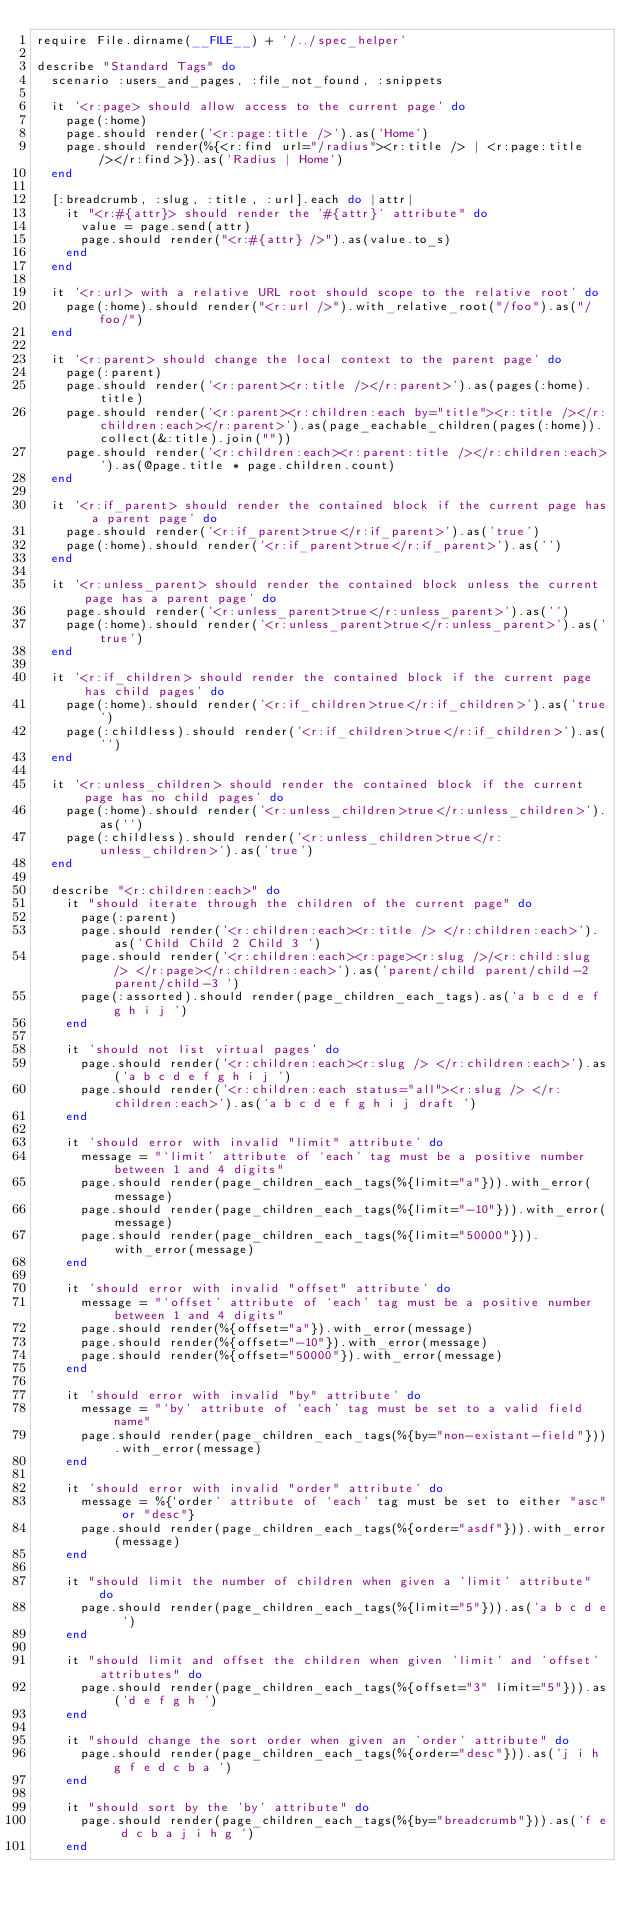<code> <loc_0><loc_0><loc_500><loc_500><_Ruby_>require File.dirname(__FILE__) + '/../spec_helper'

describe "Standard Tags" do
  scenario :users_and_pages, :file_not_found, :snippets

  it '<r:page> should allow access to the current page' do
    page(:home)
    page.should render('<r:page:title />').as('Home')
    page.should render(%{<r:find url="/radius"><r:title /> | <r:page:title /></r:find>}).as('Radius | Home')
  end

  [:breadcrumb, :slug, :title, :url].each do |attr|
    it "<r:#{attr}> should render the '#{attr}' attribute" do
      value = page.send(attr)
      page.should render("<r:#{attr} />").as(value.to_s)
    end
  end

  it '<r:url> with a relative URL root should scope to the relative root' do
    page(:home).should render("<r:url />").with_relative_root("/foo").as("/foo/")
  end

  it '<r:parent> should change the local context to the parent page' do
    page(:parent)
    page.should render('<r:parent><r:title /></r:parent>').as(pages(:home).title)
    page.should render('<r:parent><r:children:each by="title"><r:title /></r:children:each></r:parent>').as(page_eachable_children(pages(:home)).collect(&:title).join(""))
    page.should render('<r:children:each><r:parent:title /></r:children:each>').as(@page.title * page.children.count)
  end

  it '<r:if_parent> should render the contained block if the current page has a parent page' do
    page.should render('<r:if_parent>true</r:if_parent>').as('true')
    page(:home).should render('<r:if_parent>true</r:if_parent>').as('')
  end

  it '<r:unless_parent> should render the contained block unless the current page has a parent page' do
    page.should render('<r:unless_parent>true</r:unless_parent>').as('')
    page(:home).should render('<r:unless_parent>true</r:unless_parent>').as('true')
  end

  it '<r:if_children> should render the contained block if the current page has child pages' do
    page(:home).should render('<r:if_children>true</r:if_children>').as('true')
    page(:childless).should render('<r:if_children>true</r:if_children>').as('')
  end

  it '<r:unless_children> should render the contained block if the current page has no child pages' do
    page(:home).should render('<r:unless_children>true</r:unless_children>').as('')
    page(:childless).should render('<r:unless_children>true</r:unless_children>').as('true')
  end

  describe "<r:children:each>" do
    it "should iterate through the children of the current page" do
      page(:parent)
      page.should render('<r:children:each><r:title /> </r:children:each>').as('Child Child 2 Child 3 ')
      page.should render('<r:children:each><r:page><r:slug />/<r:child:slug /> </r:page></r:children:each>').as('parent/child parent/child-2 parent/child-3 ')
      page(:assorted).should render(page_children_each_tags).as('a b c d e f g h i j ')
    end

    it 'should not list virtual pages' do
      page.should render('<r:children:each><r:slug /> </r:children:each>').as('a b c d e f g h i j ')
      page.should render('<r:children:each status="all"><r:slug /> </r:children:each>').as('a b c d e f g h i j draft ')
    end

    it 'should error with invalid "limit" attribute' do
      message = "`limit' attribute of `each' tag must be a positive number between 1 and 4 digits"
      page.should render(page_children_each_tags(%{limit="a"})).with_error(message)
      page.should render(page_children_each_tags(%{limit="-10"})).with_error(message)
      page.should render(page_children_each_tags(%{limit="50000"})).with_error(message)
    end

    it 'should error with invalid "offset" attribute' do
      message = "`offset' attribute of `each' tag must be a positive number between 1 and 4 digits"
      page.should render(%{offset="a"}).with_error(message)
      page.should render(%{offset="-10"}).with_error(message)
      page.should render(%{offset="50000"}).with_error(message)
    end

    it 'should error with invalid "by" attribute' do
      message = "`by' attribute of `each' tag must be set to a valid field name"
      page.should render(page_children_each_tags(%{by="non-existant-field"})).with_error(message)
    end

    it 'should error with invalid "order" attribute' do
      message = %{`order' attribute of `each' tag must be set to either "asc" or "desc"}
      page.should render(page_children_each_tags(%{order="asdf"})).with_error(message)
    end

    it "should limit the number of children when given a 'limit' attribute" do
      page.should render(page_children_each_tags(%{limit="5"})).as('a b c d e ')
    end

    it "should limit and offset the children when given 'limit' and 'offset' attributes" do
      page.should render(page_children_each_tags(%{offset="3" limit="5"})).as('d e f g h ')
    end

    it "should change the sort order when given an 'order' attribute" do
      page.should render(page_children_each_tags(%{order="desc"})).as('j i h g f e d c b a ')
    end

    it "should sort by the 'by' attribute" do
      page.should render(page_children_each_tags(%{by="breadcrumb"})).as('f e d c b a j i h g ')
    end
</code> 